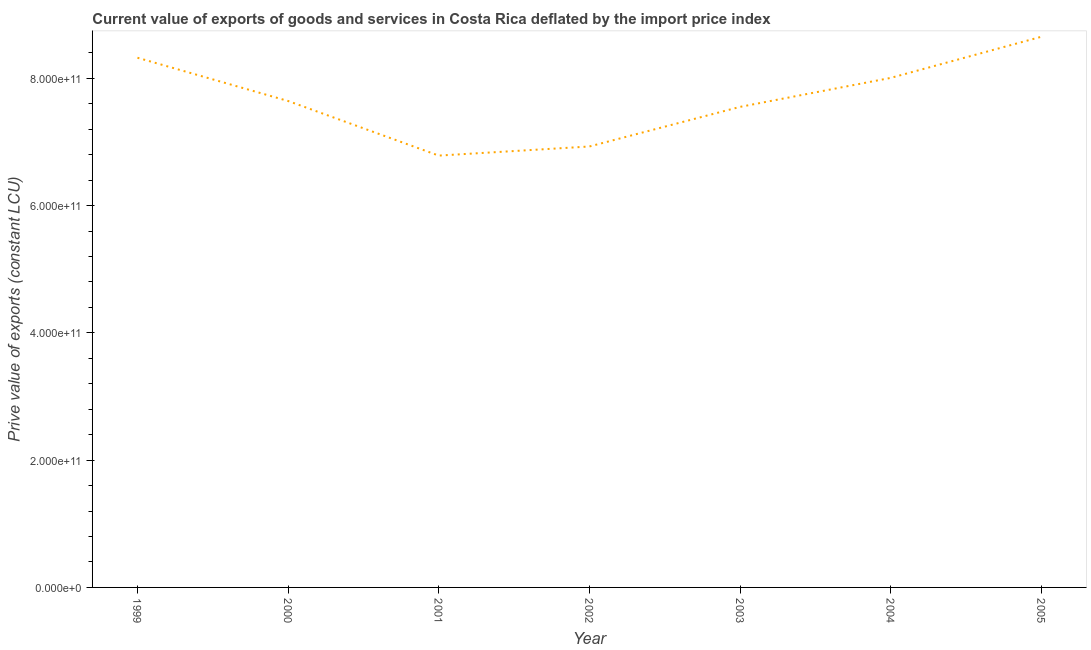What is the price value of exports in 2004?
Make the answer very short. 8.01e+11. Across all years, what is the maximum price value of exports?
Give a very brief answer. 8.65e+11. Across all years, what is the minimum price value of exports?
Your response must be concise. 6.79e+11. In which year was the price value of exports maximum?
Give a very brief answer. 2005. What is the sum of the price value of exports?
Your response must be concise. 5.39e+12. What is the difference between the price value of exports in 2001 and 2004?
Keep it short and to the point. -1.22e+11. What is the average price value of exports per year?
Offer a terse response. 7.70e+11. What is the median price value of exports?
Offer a terse response. 7.64e+11. In how many years, is the price value of exports greater than 320000000000 LCU?
Offer a very short reply. 7. Do a majority of the years between 2005 and 2002 (inclusive) have price value of exports greater than 480000000000 LCU?
Keep it short and to the point. Yes. What is the ratio of the price value of exports in 2002 to that in 2005?
Offer a very short reply. 0.8. Is the difference between the price value of exports in 1999 and 2004 greater than the difference between any two years?
Ensure brevity in your answer.  No. What is the difference between the highest and the second highest price value of exports?
Provide a succinct answer. 3.30e+1. Is the sum of the price value of exports in 2002 and 2005 greater than the maximum price value of exports across all years?
Provide a short and direct response. Yes. What is the difference between the highest and the lowest price value of exports?
Ensure brevity in your answer.  1.87e+11. How many lines are there?
Your answer should be very brief. 1. What is the difference between two consecutive major ticks on the Y-axis?
Your answer should be compact. 2.00e+11. Are the values on the major ticks of Y-axis written in scientific E-notation?
Your answer should be compact. Yes. Does the graph contain any zero values?
Provide a succinct answer. No. Does the graph contain grids?
Give a very brief answer. No. What is the title of the graph?
Keep it short and to the point. Current value of exports of goods and services in Costa Rica deflated by the import price index. What is the label or title of the X-axis?
Your response must be concise. Year. What is the label or title of the Y-axis?
Offer a terse response. Prive value of exports (constant LCU). What is the Prive value of exports (constant LCU) in 1999?
Provide a succinct answer. 8.32e+11. What is the Prive value of exports (constant LCU) in 2000?
Your response must be concise. 7.64e+11. What is the Prive value of exports (constant LCU) of 2001?
Offer a terse response. 6.79e+11. What is the Prive value of exports (constant LCU) in 2002?
Give a very brief answer. 6.93e+11. What is the Prive value of exports (constant LCU) in 2003?
Give a very brief answer. 7.55e+11. What is the Prive value of exports (constant LCU) of 2004?
Offer a very short reply. 8.01e+11. What is the Prive value of exports (constant LCU) in 2005?
Make the answer very short. 8.65e+11. What is the difference between the Prive value of exports (constant LCU) in 1999 and 2000?
Make the answer very short. 6.80e+1. What is the difference between the Prive value of exports (constant LCU) in 1999 and 2001?
Offer a very short reply. 1.54e+11. What is the difference between the Prive value of exports (constant LCU) in 1999 and 2002?
Provide a short and direct response. 1.39e+11. What is the difference between the Prive value of exports (constant LCU) in 1999 and 2003?
Your answer should be compact. 7.72e+1. What is the difference between the Prive value of exports (constant LCU) in 1999 and 2004?
Provide a short and direct response. 3.17e+1. What is the difference between the Prive value of exports (constant LCU) in 1999 and 2005?
Keep it short and to the point. -3.30e+1. What is the difference between the Prive value of exports (constant LCU) in 2000 and 2001?
Offer a very short reply. 8.58e+1. What is the difference between the Prive value of exports (constant LCU) in 2000 and 2002?
Offer a terse response. 7.15e+1. What is the difference between the Prive value of exports (constant LCU) in 2000 and 2003?
Offer a terse response. 9.26e+09. What is the difference between the Prive value of exports (constant LCU) in 2000 and 2004?
Your response must be concise. -3.63e+1. What is the difference between the Prive value of exports (constant LCU) in 2000 and 2005?
Offer a terse response. -1.01e+11. What is the difference between the Prive value of exports (constant LCU) in 2001 and 2002?
Provide a succinct answer. -1.43e+1. What is the difference between the Prive value of exports (constant LCU) in 2001 and 2003?
Provide a succinct answer. -7.66e+1. What is the difference between the Prive value of exports (constant LCU) in 2001 and 2004?
Ensure brevity in your answer.  -1.22e+11. What is the difference between the Prive value of exports (constant LCU) in 2001 and 2005?
Offer a very short reply. -1.87e+11. What is the difference between the Prive value of exports (constant LCU) in 2002 and 2003?
Keep it short and to the point. -6.22e+1. What is the difference between the Prive value of exports (constant LCU) in 2002 and 2004?
Make the answer very short. -1.08e+11. What is the difference between the Prive value of exports (constant LCU) in 2002 and 2005?
Your response must be concise. -1.72e+11. What is the difference between the Prive value of exports (constant LCU) in 2003 and 2004?
Offer a very short reply. -4.55e+1. What is the difference between the Prive value of exports (constant LCU) in 2003 and 2005?
Offer a very short reply. -1.10e+11. What is the difference between the Prive value of exports (constant LCU) in 2004 and 2005?
Your answer should be very brief. -6.46e+1. What is the ratio of the Prive value of exports (constant LCU) in 1999 to that in 2000?
Your answer should be compact. 1.09. What is the ratio of the Prive value of exports (constant LCU) in 1999 to that in 2001?
Your answer should be compact. 1.23. What is the ratio of the Prive value of exports (constant LCU) in 1999 to that in 2002?
Keep it short and to the point. 1.2. What is the ratio of the Prive value of exports (constant LCU) in 1999 to that in 2003?
Give a very brief answer. 1.1. What is the ratio of the Prive value of exports (constant LCU) in 1999 to that in 2005?
Give a very brief answer. 0.96. What is the ratio of the Prive value of exports (constant LCU) in 2000 to that in 2001?
Offer a very short reply. 1.13. What is the ratio of the Prive value of exports (constant LCU) in 2000 to that in 2002?
Your answer should be very brief. 1.1. What is the ratio of the Prive value of exports (constant LCU) in 2000 to that in 2003?
Ensure brevity in your answer.  1.01. What is the ratio of the Prive value of exports (constant LCU) in 2000 to that in 2004?
Your answer should be very brief. 0.95. What is the ratio of the Prive value of exports (constant LCU) in 2000 to that in 2005?
Provide a short and direct response. 0.88. What is the ratio of the Prive value of exports (constant LCU) in 2001 to that in 2002?
Offer a very short reply. 0.98. What is the ratio of the Prive value of exports (constant LCU) in 2001 to that in 2003?
Offer a terse response. 0.9. What is the ratio of the Prive value of exports (constant LCU) in 2001 to that in 2004?
Offer a very short reply. 0.85. What is the ratio of the Prive value of exports (constant LCU) in 2001 to that in 2005?
Ensure brevity in your answer.  0.78. What is the ratio of the Prive value of exports (constant LCU) in 2002 to that in 2003?
Keep it short and to the point. 0.92. What is the ratio of the Prive value of exports (constant LCU) in 2002 to that in 2004?
Ensure brevity in your answer.  0.86. What is the ratio of the Prive value of exports (constant LCU) in 2002 to that in 2005?
Provide a short and direct response. 0.8. What is the ratio of the Prive value of exports (constant LCU) in 2003 to that in 2004?
Provide a succinct answer. 0.94. What is the ratio of the Prive value of exports (constant LCU) in 2003 to that in 2005?
Keep it short and to the point. 0.87. What is the ratio of the Prive value of exports (constant LCU) in 2004 to that in 2005?
Provide a short and direct response. 0.93. 